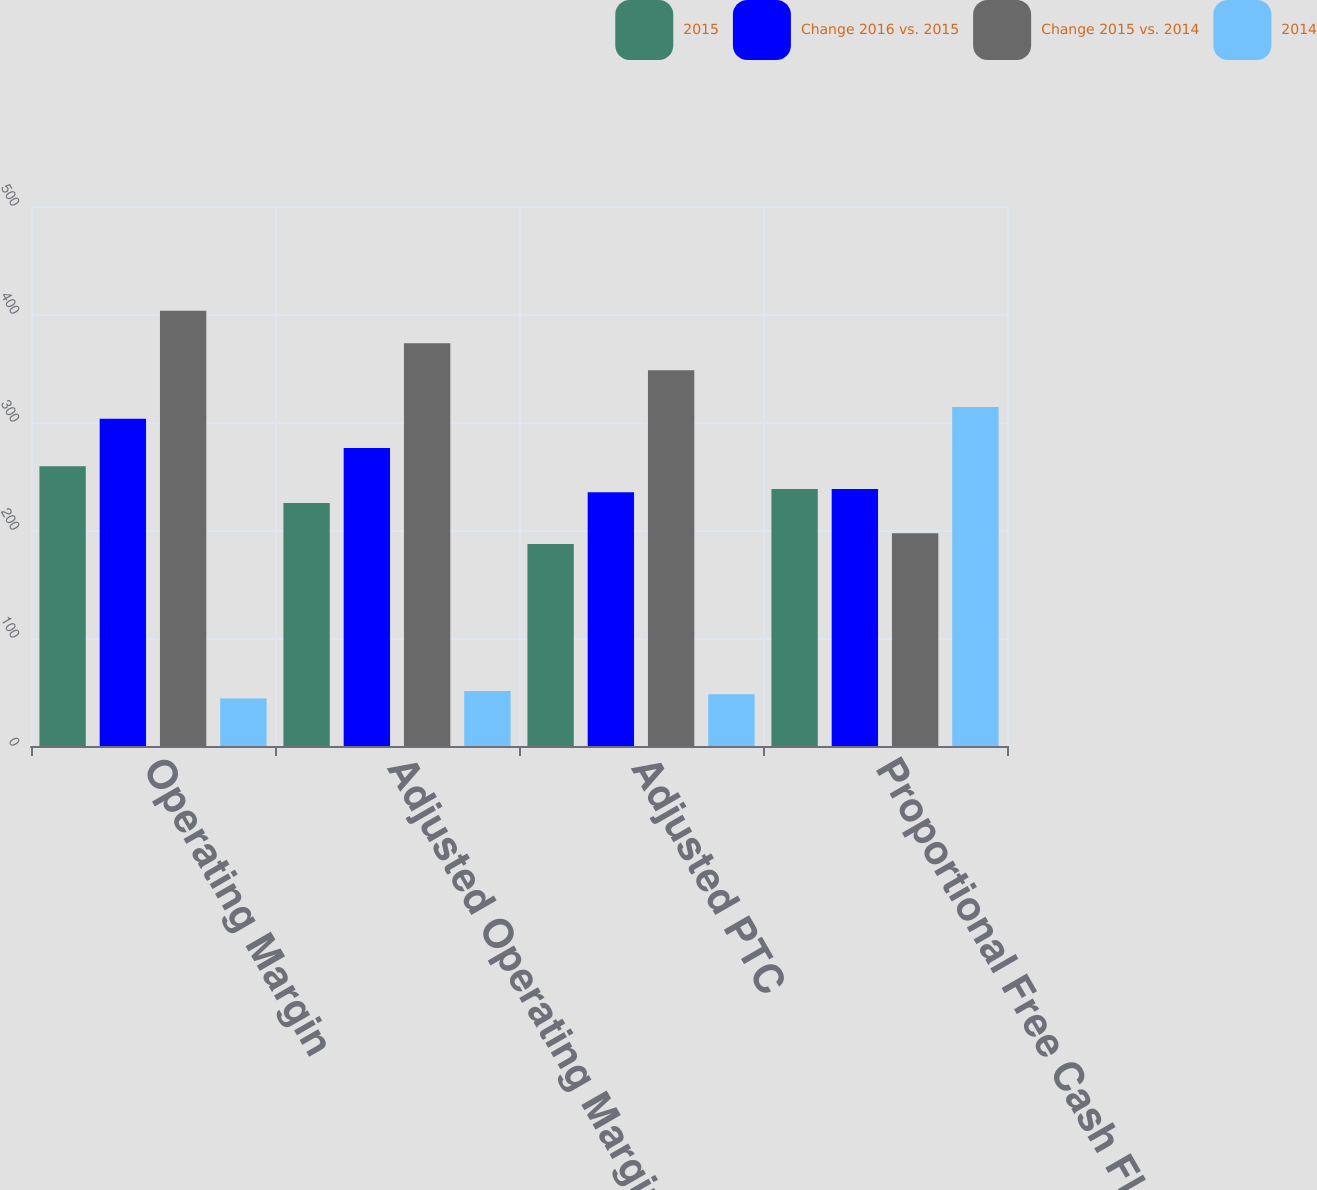<chart> <loc_0><loc_0><loc_500><loc_500><stacked_bar_chart><ecel><fcel>Operating Margin<fcel>Adjusted Operating Margin<fcel>Adjusted PTC<fcel>Proportional Free Cash Flow<nl><fcel>2015<fcel>259<fcel>225<fcel>187<fcel>238<nl><fcel>Change 2016 vs. 2015<fcel>303<fcel>276<fcel>235<fcel>238<nl><fcel>Change 2015 vs. 2014<fcel>403<fcel>373<fcel>348<fcel>197<nl><fcel>2014<fcel>44<fcel>51<fcel>48<fcel>314<nl></chart> 